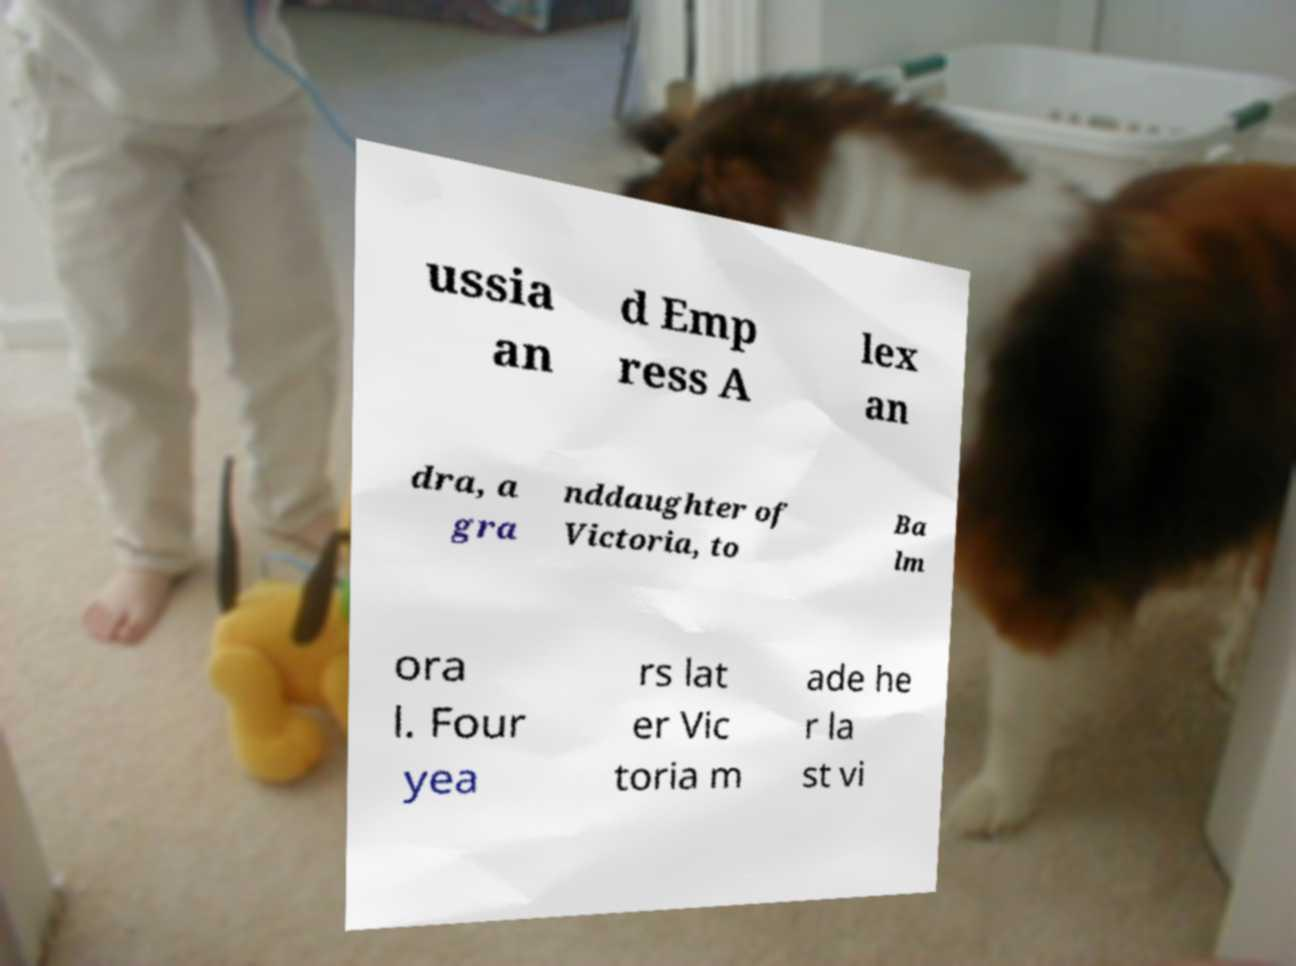Could you assist in decoding the text presented in this image and type it out clearly? ussia an d Emp ress A lex an dra, a gra nddaughter of Victoria, to Ba lm ora l. Four yea rs lat er Vic toria m ade he r la st vi 